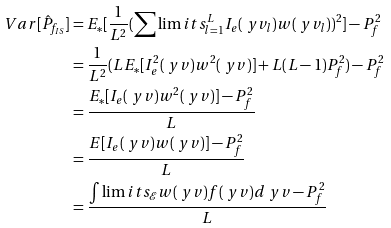<formula> <loc_0><loc_0><loc_500><loc_500>V a r [ \hat { P } _ { f _ { I S } } ] & = E _ { * } [ \frac { 1 } { L ^ { 2 } } ( \sum \lim i t s _ { l = 1 } ^ { L } I _ { e } ( \ y v _ { l } ) w ( \ y v _ { l } ) ) ^ { 2 } ] - P _ { f } ^ { 2 } \\ & = \frac { 1 } { L ^ { 2 } } ( L E _ { * } [ I _ { e } ^ { 2 } ( \ y v ) w ^ { 2 } ( \ y v ) ] + L ( L - 1 ) P _ { f } ^ { 2 } ) - P _ { f } ^ { 2 } \\ & = \frac { E _ { * } [ I _ { e } ( \ y v ) w ^ { 2 } ( \ y v ) ] - P _ { f } ^ { 2 } } { L } \\ & = \frac { E [ I _ { e } ( \ y v ) w ( \ y v ) ] - P _ { f } ^ { 2 } } { L } \\ & = \frac { \int \lim i t s _ { \mathcal { E } } w ( \ y v ) f ( \ y v ) d \ y v - P _ { f } ^ { 2 } } { L }</formula> 